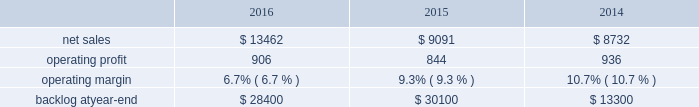2015 compared to 2014 mfc 2019s net sales in 2015 decreased $ 322 million , or 5% ( 5 % ) , compared to the same period in 2014 .
The decrease was attributable to lower net sales of approximately $ 345 million for air and missile defense programs due to fewer deliveries ( primarily pac-3 ) and lower volume ( primarily thaad ) ; and approximately $ 85 million for tactical missile programs due to fewer deliveries ( primarily guided multiple launch rocket system ( gmlrs ) ) and joint air-to-surface standoff missile , partially offset by increased deliveries for hellfire .
These decreases were partially offset by higher net sales of approximately $ 55 million for energy solutions programs due to increased volume .
Mfc 2019s operating profit in 2015 decreased $ 62 million , or 5% ( 5 % ) , compared to 2014 .
The decrease was attributable to lower operating profit of approximately $ 100 million for fire control programs due primarily to lower risk retirements ( primarily lantirn and sniper ) ; and approximately $ 65 million for tactical missile programs due to lower risk retirements ( primarily hellfire and gmlrs ) and fewer deliveries .
These decreases were partially offset by higher operating profit of approximately $ 75 million for air and missile defense programs due to increased risk retirements ( primarily thaad ) .
Adjustments not related to volume , including net profit booking rate adjustments and other matters , were approximately $ 60 million lower in 2015 compared to 2014 .
Backlog backlog decreased in 2016 compared to 2015 primarily due to lower orders on pac-3 , hellfire , and jassm .
Backlog increased in 2015 compared to 2014 primarily due to higher orders on pac-3 , lantirn/sniper and certain tactical missile programs , partially offset by lower orders on thaad .
Trends we expect mfc 2019s net sales to increase in the mid-single digit percentage range in 2017 as compared to 2016 driven primarily by our air and missile defense programs .
Operating profit is expected to be flat or increase slightly .
Accordingly , operating profit margin is expected to decline from 2016 levels as a result of contract mix and fewer risk retirements in 2017 compared to 2016 .
Rotary and mission systems as previously described , on november 6 , 2015 , we acquired sikorsky and aligned the sikorsky business under our rms business segment .
The 2015 results of the acquired sikorsky business have been included in our financial results from the november 6 , 2015 acquisition date through december 31 , 2015 .
As a result , our consolidated operating results and rms business segment operating results for the year ended december 31 , 2015 do not reflect a full year of sikorsky operations .
Our rms business segment provides design , manufacture , service and support for a variety of military and civil helicopters , ship and submarine mission and combat systems ; mission systems and sensors for rotary and fixed-wing aircraft ; sea and land-based missile defense systems ; radar systems ; the littoral combat ship ( lcs ) ; simulation and training services ; and unmanned systems and technologies .
In addition , rms supports the needs of government customers in cybersecurity and delivers communication and command and control capabilities through complex mission solutions for defense applications .
Rms 2019 major programs include black hawk and seahawk helicopters , aegis combat system ( aegis ) , lcs , space fence , advanced hawkeye radar system , tpq-53 radar system , ch-53k development helicopter , and vh-92a helicopter program .
Rms 2019 operating results included the following ( in millions ) : .
2016 compared to 2015 rms 2019 net sales in 2016 increased $ 4.4 billion , or 48% ( 48 % ) , compared to 2015 .
The increase was primarily attributable to higher net sales of approximately $ 4.6 billion from sikorsky , which was acquired on november 6 , 2015 .
Net sales for 2015 include sikorsky 2019s results subsequent to the acquisition date , net of certain revenue adjustments required to account for the acquisition of this business .
This increase was partially offset by lower net sales of approximately $ 70 million for training .
What are the total operating expenses in 2015? 
Computations: (9091 - 844)
Answer: 8247.0. 